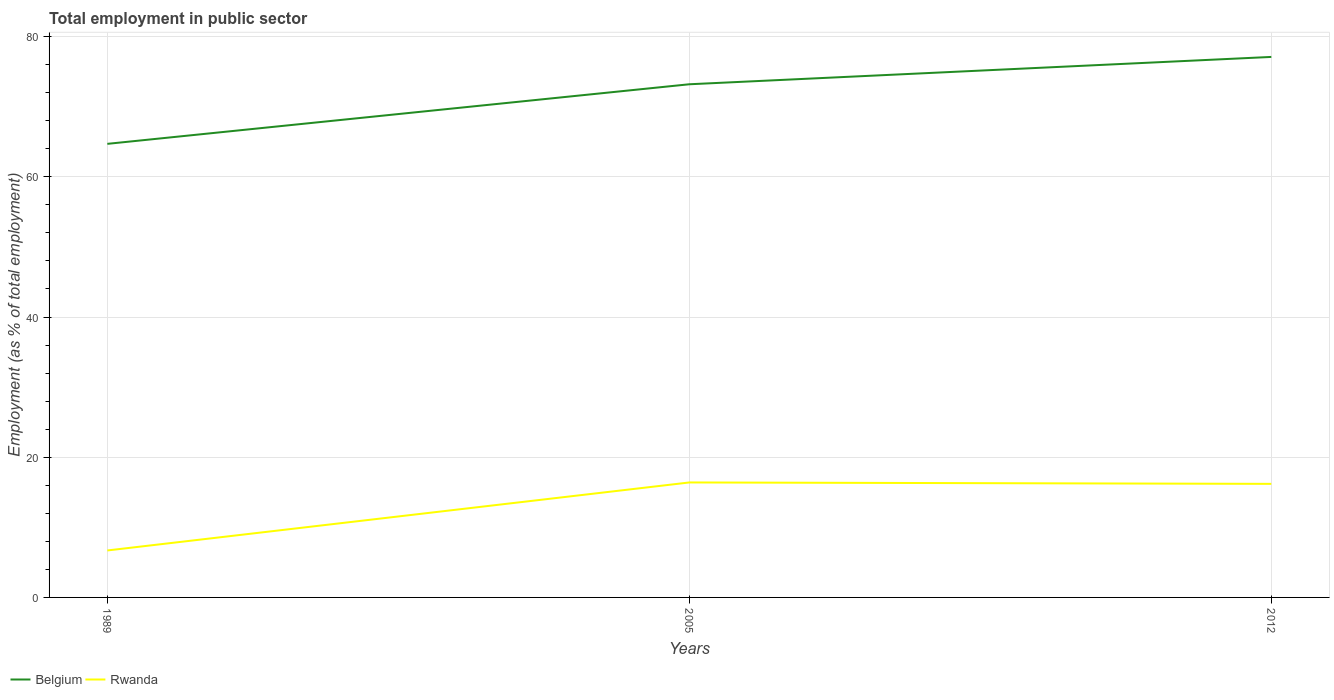How many different coloured lines are there?
Your answer should be compact. 2. Does the line corresponding to Rwanda intersect with the line corresponding to Belgium?
Ensure brevity in your answer.  No. Across all years, what is the maximum employment in public sector in Rwanda?
Offer a terse response. 6.7. In which year was the employment in public sector in Belgium maximum?
Give a very brief answer. 1989. What is the total employment in public sector in Belgium in the graph?
Provide a short and direct response. -3.9. What is the difference between the highest and the second highest employment in public sector in Rwanda?
Ensure brevity in your answer.  9.7. What is the difference between two consecutive major ticks on the Y-axis?
Your answer should be very brief. 20. Does the graph contain grids?
Provide a succinct answer. Yes. Where does the legend appear in the graph?
Provide a succinct answer. Bottom left. How many legend labels are there?
Keep it short and to the point. 2. What is the title of the graph?
Offer a terse response. Total employment in public sector. What is the label or title of the Y-axis?
Ensure brevity in your answer.  Employment (as % of total employment). What is the Employment (as % of total employment) of Belgium in 1989?
Your answer should be compact. 64.7. What is the Employment (as % of total employment) in Rwanda in 1989?
Keep it short and to the point. 6.7. What is the Employment (as % of total employment) of Belgium in 2005?
Your answer should be compact. 73.2. What is the Employment (as % of total employment) of Rwanda in 2005?
Your response must be concise. 16.4. What is the Employment (as % of total employment) in Belgium in 2012?
Offer a very short reply. 77.1. What is the Employment (as % of total employment) of Rwanda in 2012?
Your response must be concise. 16.2. Across all years, what is the maximum Employment (as % of total employment) in Belgium?
Provide a short and direct response. 77.1. Across all years, what is the maximum Employment (as % of total employment) in Rwanda?
Provide a succinct answer. 16.4. Across all years, what is the minimum Employment (as % of total employment) in Belgium?
Offer a very short reply. 64.7. Across all years, what is the minimum Employment (as % of total employment) in Rwanda?
Your answer should be very brief. 6.7. What is the total Employment (as % of total employment) in Belgium in the graph?
Your answer should be very brief. 215. What is the total Employment (as % of total employment) of Rwanda in the graph?
Provide a short and direct response. 39.3. What is the difference between the Employment (as % of total employment) of Rwanda in 1989 and that in 2005?
Offer a terse response. -9.7. What is the difference between the Employment (as % of total employment) of Belgium in 2005 and that in 2012?
Provide a succinct answer. -3.9. What is the difference between the Employment (as % of total employment) in Belgium in 1989 and the Employment (as % of total employment) in Rwanda in 2005?
Offer a very short reply. 48.3. What is the difference between the Employment (as % of total employment) of Belgium in 1989 and the Employment (as % of total employment) of Rwanda in 2012?
Your answer should be compact. 48.5. What is the difference between the Employment (as % of total employment) of Belgium in 2005 and the Employment (as % of total employment) of Rwanda in 2012?
Give a very brief answer. 57. What is the average Employment (as % of total employment) of Belgium per year?
Provide a short and direct response. 71.67. In the year 2005, what is the difference between the Employment (as % of total employment) in Belgium and Employment (as % of total employment) in Rwanda?
Your response must be concise. 56.8. In the year 2012, what is the difference between the Employment (as % of total employment) in Belgium and Employment (as % of total employment) in Rwanda?
Keep it short and to the point. 60.9. What is the ratio of the Employment (as % of total employment) in Belgium in 1989 to that in 2005?
Your answer should be compact. 0.88. What is the ratio of the Employment (as % of total employment) in Rwanda in 1989 to that in 2005?
Your answer should be compact. 0.41. What is the ratio of the Employment (as % of total employment) in Belgium in 1989 to that in 2012?
Provide a short and direct response. 0.84. What is the ratio of the Employment (as % of total employment) in Rwanda in 1989 to that in 2012?
Provide a succinct answer. 0.41. What is the ratio of the Employment (as % of total employment) in Belgium in 2005 to that in 2012?
Your answer should be very brief. 0.95. What is the ratio of the Employment (as % of total employment) in Rwanda in 2005 to that in 2012?
Give a very brief answer. 1.01. What is the difference between the highest and the second highest Employment (as % of total employment) in Belgium?
Ensure brevity in your answer.  3.9. What is the difference between the highest and the second highest Employment (as % of total employment) of Rwanda?
Keep it short and to the point. 0.2. What is the difference between the highest and the lowest Employment (as % of total employment) of Belgium?
Keep it short and to the point. 12.4. 